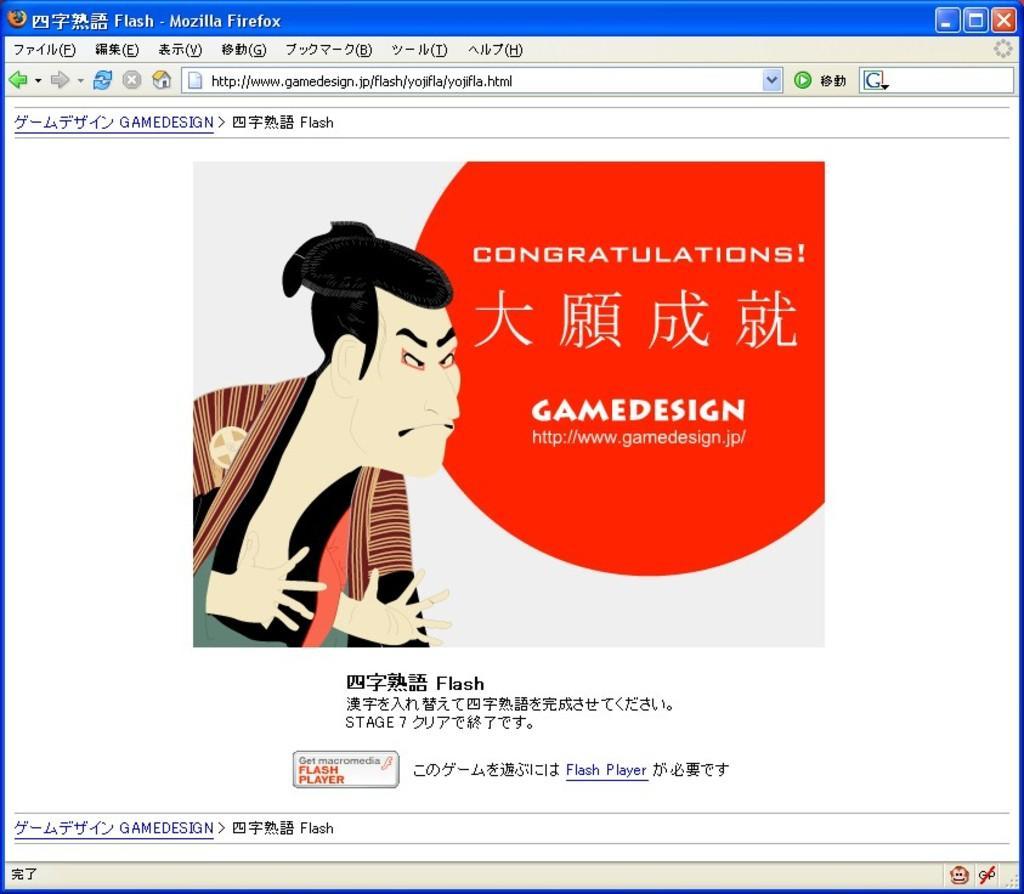Describe this image in one or two sentences. This is a web page. There is a cartoon image in this. And something is written on that. There are different icons on the page. 